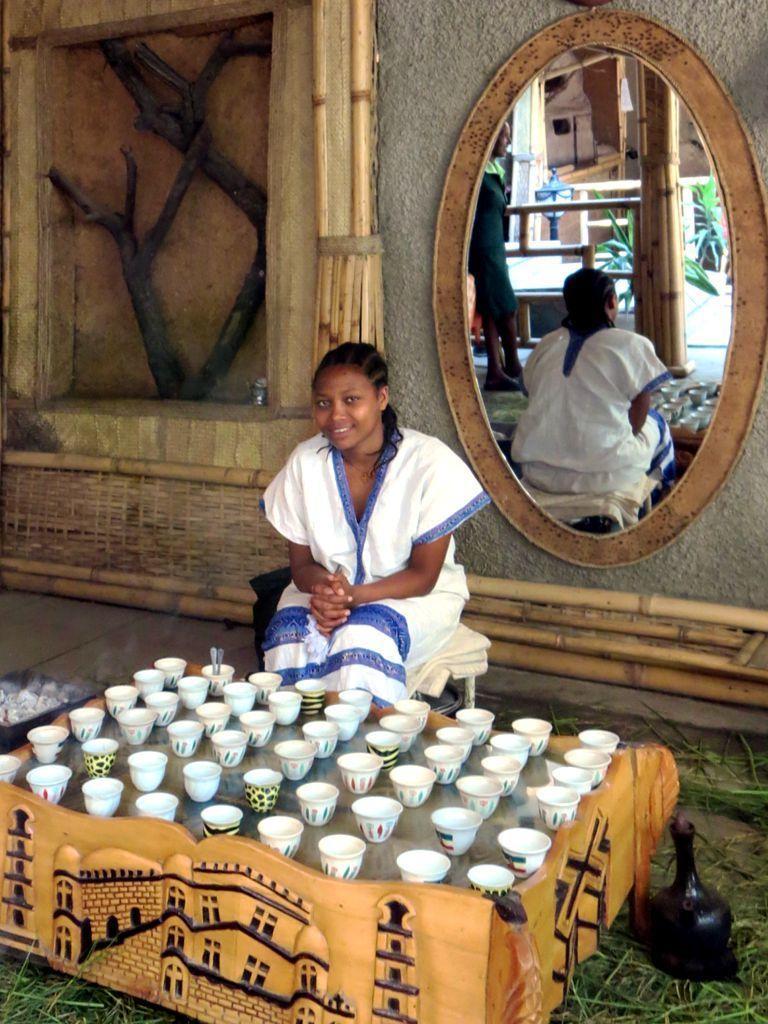Please provide a concise description of this image. In this image in the center there is one girl who is sitting on a stool, and in front of her there are cups on a box. And at the bottom there is grass and some object and there is floor, in the background there is wall, mirror and truncated tree and some wooden sticks. 